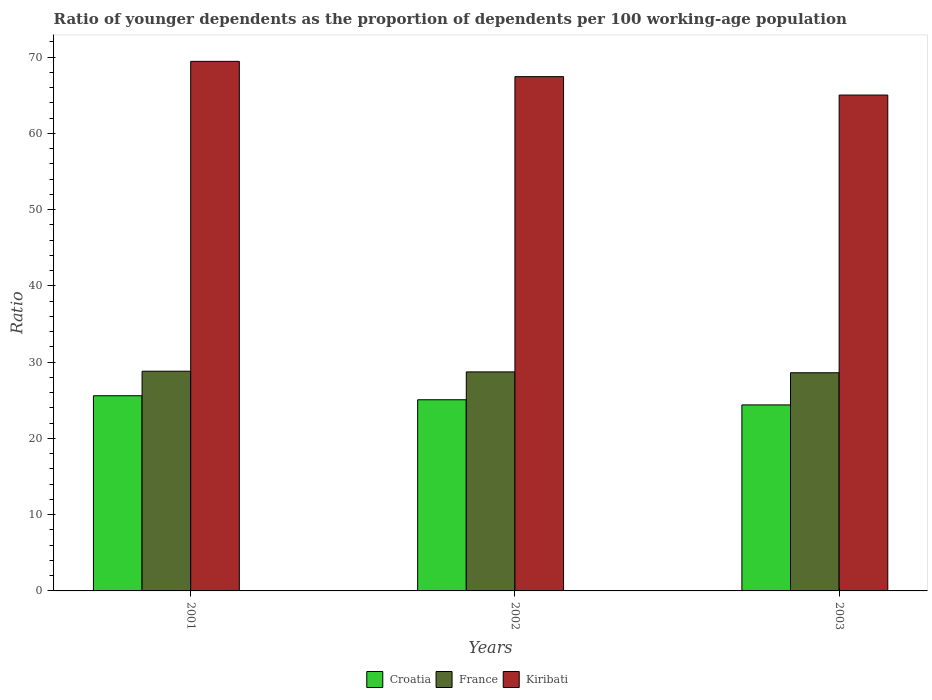How many groups of bars are there?
Offer a very short reply. 3. How many bars are there on the 2nd tick from the left?
Your response must be concise. 3. How many bars are there on the 3rd tick from the right?
Offer a very short reply. 3. In how many cases, is the number of bars for a given year not equal to the number of legend labels?
Ensure brevity in your answer.  0. What is the age dependency ratio(young) in France in 2001?
Make the answer very short. 28.81. Across all years, what is the maximum age dependency ratio(young) in Croatia?
Offer a terse response. 25.59. Across all years, what is the minimum age dependency ratio(young) in Croatia?
Ensure brevity in your answer.  24.39. In which year was the age dependency ratio(young) in Croatia maximum?
Provide a short and direct response. 2001. In which year was the age dependency ratio(young) in France minimum?
Give a very brief answer. 2003. What is the total age dependency ratio(young) in Croatia in the graph?
Make the answer very short. 75.05. What is the difference between the age dependency ratio(young) in Croatia in 2002 and that in 2003?
Your answer should be compact. 0.68. What is the difference between the age dependency ratio(young) in Croatia in 2001 and the age dependency ratio(young) in France in 2002?
Your answer should be very brief. -3.13. What is the average age dependency ratio(young) in Kiribati per year?
Your response must be concise. 67.3. In the year 2003, what is the difference between the age dependency ratio(young) in France and age dependency ratio(young) in Kiribati?
Your answer should be compact. -36.42. What is the ratio of the age dependency ratio(young) in Kiribati in 2002 to that in 2003?
Ensure brevity in your answer.  1.04. What is the difference between the highest and the second highest age dependency ratio(young) in Croatia?
Your response must be concise. 0.53. What is the difference between the highest and the lowest age dependency ratio(young) in Croatia?
Ensure brevity in your answer.  1.2. What does the 3rd bar from the left in 2002 represents?
Your response must be concise. Kiribati. What does the 1st bar from the right in 2001 represents?
Keep it short and to the point. Kiribati. Are all the bars in the graph horizontal?
Your answer should be very brief. No. How many years are there in the graph?
Your answer should be compact. 3. What is the difference between two consecutive major ticks on the Y-axis?
Offer a terse response. 10. Are the values on the major ticks of Y-axis written in scientific E-notation?
Your answer should be very brief. No. Does the graph contain any zero values?
Give a very brief answer. No. What is the title of the graph?
Your answer should be compact. Ratio of younger dependents as the proportion of dependents per 100 working-age population. What is the label or title of the X-axis?
Make the answer very short. Years. What is the label or title of the Y-axis?
Provide a succinct answer. Ratio. What is the Ratio of Croatia in 2001?
Ensure brevity in your answer.  25.59. What is the Ratio of France in 2001?
Your answer should be very brief. 28.81. What is the Ratio in Kiribati in 2001?
Keep it short and to the point. 69.45. What is the Ratio of Croatia in 2002?
Keep it short and to the point. 25.07. What is the Ratio in France in 2002?
Your answer should be compact. 28.72. What is the Ratio of Kiribati in 2002?
Your answer should be very brief. 67.44. What is the Ratio of Croatia in 2003?
Offer a terse response. 24.39. What is the Ratio in France in 2003?
Your answer should be very brief. 28.61. What is the Ratio in Kiribati in 2003?
Provide a succinct answer. 65.03. Across all years, what is the maximum Ratio of Croatia?
Ensure brevity in your answer.  25.59. Across all years, what is the maximum Ratio in France?
Provide a short and direct response. 28.81. Across all years, what is the maximum Ratio of Kiribati?
Make the answer very short. 69.45. Across all years, what is the minimum Ratio of Croatia?
Ensure brevity in your answer.  24.39. Across all years, what is the minimum Ratio in France?
Give a very brief answer. 28.61. Across all years, what is the minimum Ratio of Kiribati?
Offer a very short reply. 65.03. What is the total Ratio of Croatia in the graph?
Make the answer very short. 75.05. What is the total Ratio in France in the graph?
Provide a succinct answer. 86.14. What is the total Ratio in Kiribati in the graph?
Ensure brevity in your answer.  201.91. What is the difference between the Ratio in Croatia in 2001 and that in 2002?
Keep it short and to the point. 0.53. What is the difference between the Ratio in France in 2001 and that in 2002?
Make the answer very short. 0.09. What is the difference between the Ratio of Kiribati in 2001 and that in 2002?
Your answer should be compact. 2.01. What is the difference between the Ratio in Croatia in 2001 and that in 2003?
Make the answer very short. 1.2. What is the difference between the Ratio of France in 2001 and that in 2003?
Offer a terse response. 0.2. What is the difference between the Ratio of Kiribati in 2001 and that in 2003?
Provide a succinct answer. 4.42. What is the difference between the Ratio of Croatia in 2002 and that in 2003?
Offer a very short reply. 0.68. What is the difference between the Ratio of France in 2002 and that in 2003?
Keep it short and to the point. 0.11. What is the difference between the Ratio of Kiribati in 2002 and that in 2003?
Make the answer very short. 2.41. What is the difference between the Ratio in Croatia in 2001 and the Ratio in France in 2002?
Ensure brevity in your answer.  -3.13. What is the difference between the Ratio of Croatia in 2001 and the Ratio of Kiribati in 2002?
Give a very brief answer. -41.85. What is the difference between the Ratio of France in 2001 and the Ratio of Kiribati in 2002?
Your response must be concise. -38.63. What is the difference between the Ratio of Croatia in 2001 and the Ratio of France in 2003?
Give a very brief answer. -3.02. What is the difference between the Ratio of Croatia in 2001 and the Ratio of Kiribati in 2003?
Your answer should be very brief. -39.43. What is the difference between the Ratio in France in 2001 and the Ratio in Kiribati in 2003?
Provide a succinct answer. -36.21. What is the difference between the Ratio in Croatia in 2002 and the Ratio in France in 2003?
Give a very brief answer. -3.54. What is the difference between the Ratio of Croatia in 2002 and the Ratio of Kiribati in 2003?
Ensure brevity in your answer.  -39.96. What is the difference between the Ratio of France in 2002 and the Ratio of Kiribati in 2003?
Keep it short and to the point. -36.3. What is the average Ratio in Croatia per year?
Give a very brief answer. 25.02. What is the average Ratio of France per year?
Make the answer very short. 28.71. What is the average Ratio in Kiribati per year?
Your answer should be compact. 67.3. In the year 2001, what is the difference between the Ratio of Croatia and Ratio of France?
Offer a terse response. -3.22. In the year 2001, what is the difference between the Ratio of Croatia and Ratio of Kiribati?
Your answer should be very brief. -43.85. In the year 2001, what is the difference between the Ratio of France and Ratio of Kiribati?
Your response must be concise. -40.63. In the year 2002, what is the difference between the Ratio of Croatia and Ratio of France?
Ensure brevity in your answer.  -3.65. In the year 2002, what is the difference between the Ratio in Croatia and Ratio in Kiribati?
Keep it short and to the point. -42.37. In the year 2002, what is the difference between the Ratio of France and Ratio of Kiribati?
Offer a very short reply. -38.72. In the year 2003, what is the difference between the Ratio of Croatia and Ratio of France?
Make the answer very short. -4.22. In the year 2003, what is the difference between the Ratio of Croatia and Ratio of Kiribati?
Your response must be concise. -40.63. In the year 2003, what is the difference between the Ratio of France and Ratio of Kiribati?
Offer a very short reply. -36.42. What is the ratio of the Ratio in France in 2001 to that in 2002?
Offer a terse response. 1. What is the ratio of the Ratio of Kiribati in 2001 to that in 2002?
Offer a very short reply. 1.03. What is the ratio of the Ratio in Croatia in 2001 to that in 2003?
Provide a succinct answer. 1.05. What is the ratio of the Ratio of France in 2001 to that in 2003?
Ensure brevity in your answer.  1.01. What is the ratio of the Ratio in Kiribati in 2001 to that in 2003?
Provide a short and direct response. 1.07. What is the ratio of the Ratio of Croatia in 2002 to that in 2003?
Give a very brief answer. 1.03. What is the ratio of the Ratio in France in 2002 to that in 2003?
Ensure brevity in your answer.  1. What is the ratio of the Ratio in Kiribati in 2002 to that in 2003?
Provide a succinct answer. 1.04. What is the difference between the highest and the second highest Ratio of Croatia?
Offer a terse response. 0.53. What is the difference between the highest and the second highest Ratio of France?
Your answer should be very brief. 0.09. What is the difference between the highest and the second highest Ratio of Kiribati?
Keep it short and to the point. 2.01. What is the difference between the highest and the lowest Ratio of Croatia?
Ensure brevity in your answer.  1.2. What is the difference between the highest and the lowest Ratio in France?
Give a very brief answer. 0.2. What is the difference between the highest and the lowest Ratio of Kiribati?
Your response must be concise. 4.42. 